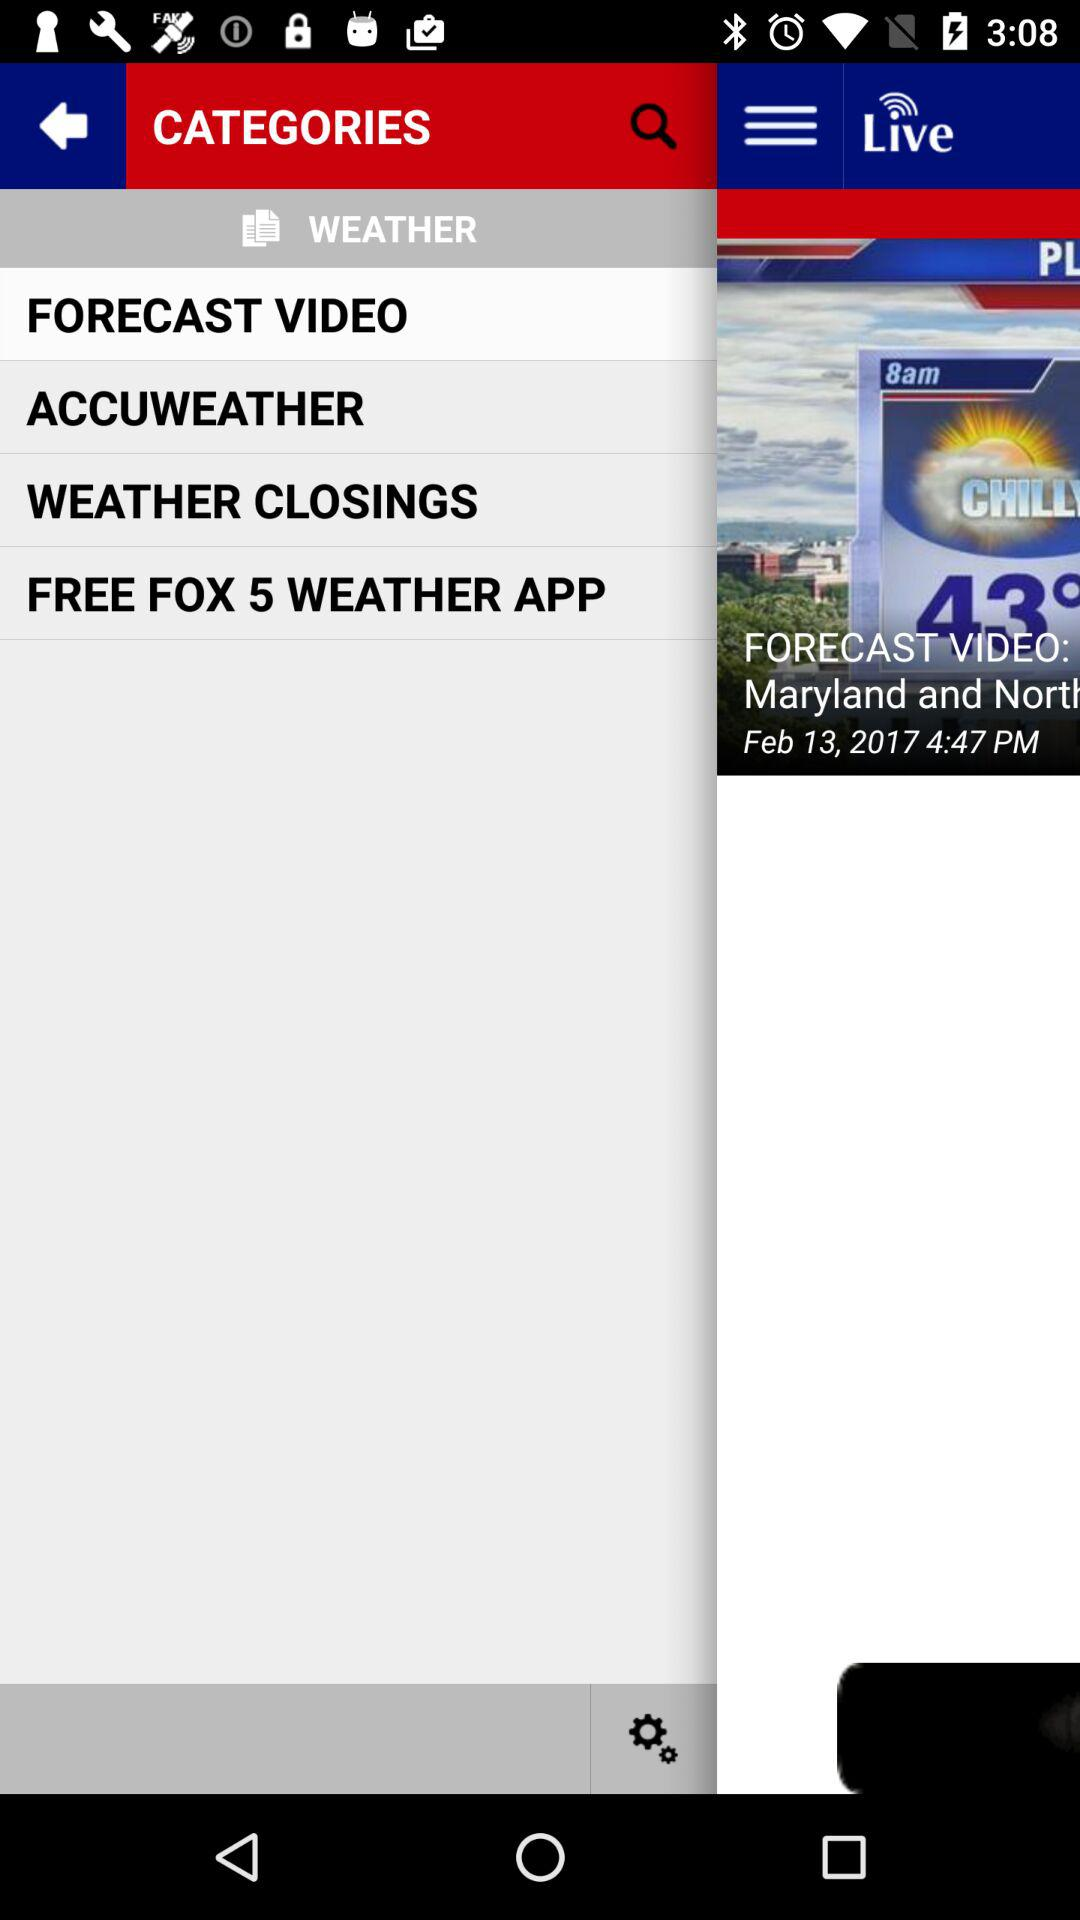At what time was the news posted? The news was posted at 4:47 PM. 